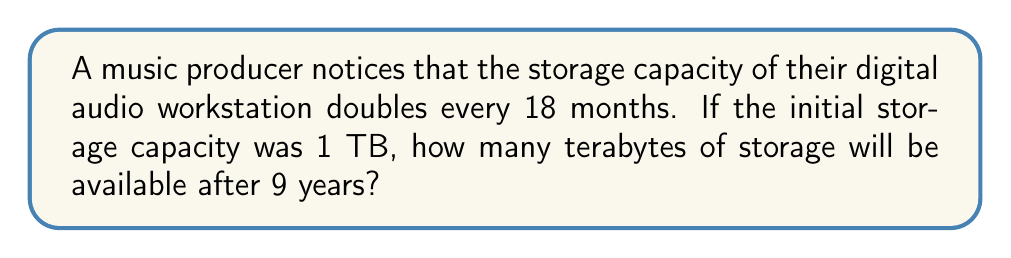Could you help me with this problem? Let's approach this step-by-step:

1) First, we need to determine how many 18-month periods are in 9 years:
   $$ \frac{9 \text{ years} \times 12 \text{ months/year}}{18 \text{ months/period}} = 6 \text{ periods} $$

2) Now, we can set up our exponential growth equation:
   $$ C = 1 \times 2^n $$
   Where:
   $C$ is the final capacity
   $1$ is the initial capacity in TB
   $2$ is the growth factor (doubling each period)
   $n$ is the number of periods (6)

3) Plugging in our values:
   $$ C = 1 \times 2^6 $$

4) Calculate:
   $$ C = 1 \times 64 = 64 $$

Therefore, after 9 years, the storage capacity will be 64 TB.
Answer: 64 TB 